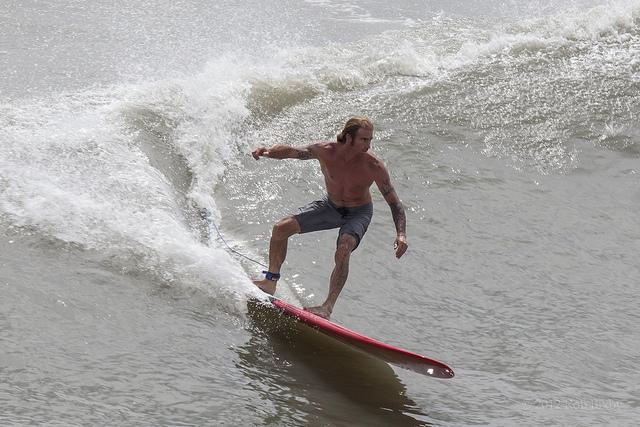What color is the surfboard?
Write a very short answer. Red. What is the man wearing?
Quick response, please. Shorts. Is this man attached to his surfboard?
Quick response, please. Yes. Is this man riding a surfboard?
Short answer required. Yes. Is he wearing the right type of suit?
Concise answer only. Yes. Is the man riding a white board?
Write a very short answer. No. How many people are surfing?
Concise answer only. 1. Is the woman surfing?
Concise answer only. Yes. What kind of suit is he wearing?
Short answer required. Swim. 